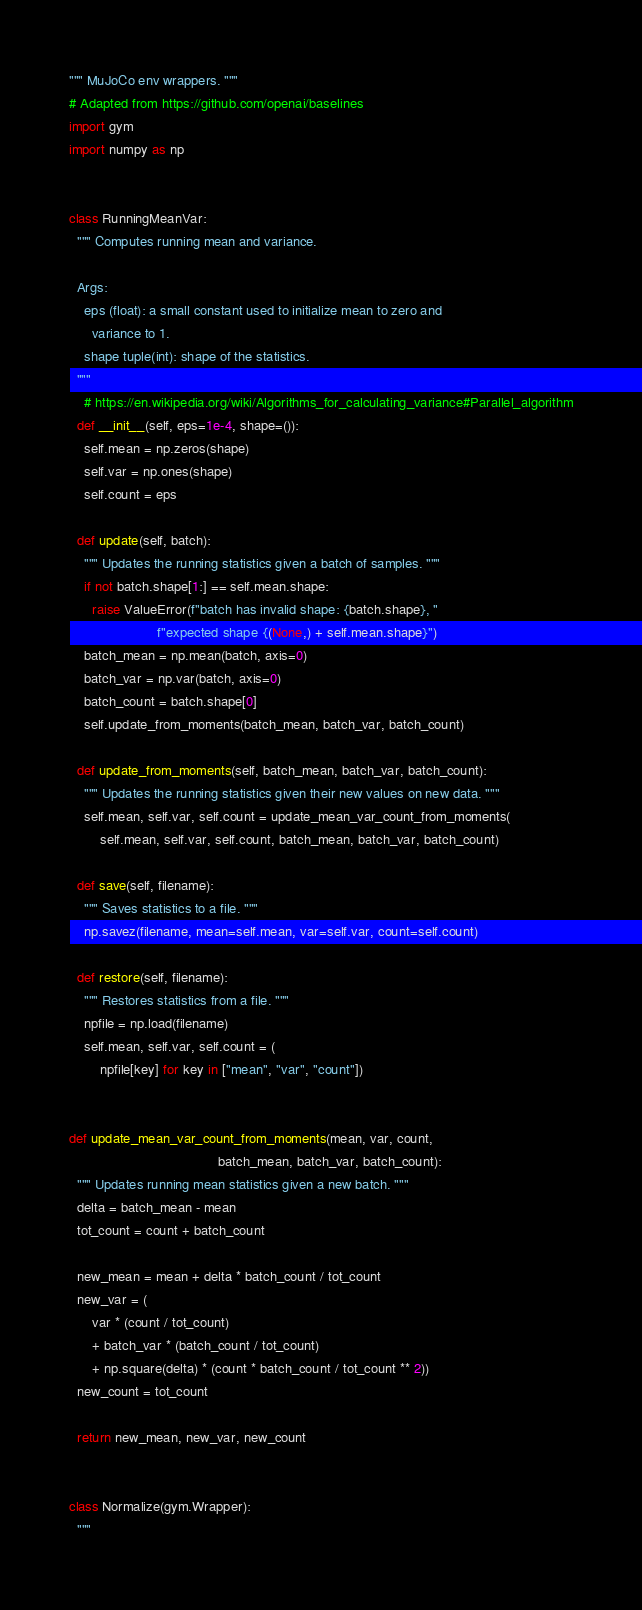<code> <loc_0><loc_0><loc_500><loc_500><_Python_>""" MuJoCo env wrappers. """
# Adapted from https://github.com/openai/baselines
import gym
import numpy as np


class RunningMeanVar:
  """ Computes running mean and variance.

  Args:
    eps (float): a small constant used to initialize mean to zero and
      variance to 1.
    shape tuple(int): shape of the statistics.
  """
    # https://en.wikipedia.org/wiki/Algorithms_for_calculating_variance#Parallel_algorithm
  def __init__(self, eps=1e-4, shape=()):
    self.mean = np.zeros(shape)
    self.var = np.ones(shape)
    self.count = eps

  def update(self, batch):
    """ Updates the running statistics given a batch of samples. """
    if not batch.shape[1:] == self.mean.shape:
      raise ValueError(f"batch has invalid shape: {batch.shape}, "
                       f"expected shape {(None,) + self.mean.shape}")
    batch_mean = np.mean(batch, axis=0)
    batch_var = np.var(batch, axis=0)
    batch_count = batch.shape[0]
    self.update_from_moments(batch_mean, batch_var, batch_count)

  def update_from_moments(self, batch_mean, batch_var, batch_count):
    """ Updates the running statistics given their new values on new data. """
    self.mean, self.var, self.count = update_mean_var_count_from_moments(
        self.mean, self.var, self.count, batch_mean, batch_var, batch_count)

  def save(self, filename):
    """ Saves statistics to a file. """
    np.savez(filename, mean=self.mean, var=self.var, count=self.count)

  def restore(self, filename):
    """ Restores statistics from a file. """
    npfile = np.load(filename)
    self.mean, self.var, self.count = (
        npfile[key] for key in ["mean", "var", "count"])


def update_mean_var_count_from_moments(mean, var, count,
                                       batch_mean, batch_var, batch_count):
  """ Updates running mean statistics given a new batch. """
  delta = batch_mean - mean
  tot_count = count + batch_count

  new_mean = mean + delta * batch_count / tot_count
  new_var = (
      var * (count / tot_count)
      + batch_var * (batch_count / tot_count)
      + np.square(delta) * (count * batch_count / tot_count ** 2))
  new_count = tot_count

  return new_mean, new_var, new_count


class Normalize(gym.Wrapper):
  """</code> 